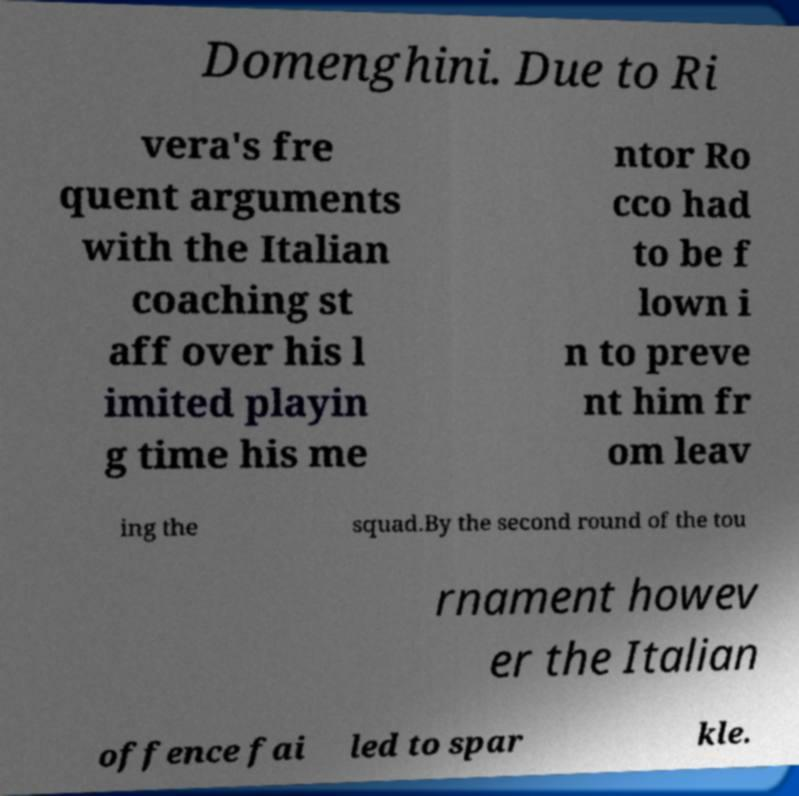Can you accurately transcribe the text from the provided image for me? Domenghini. Due to Ri vera's fre quent arguments with the Italian coaching st aff over his l imited playin g time his me ntor Ro cco had to be f lown i n to preve nt him fr om leav ing the squad.By the second round of the tou rnament howev er the Italian offence fai led to spar kle. 